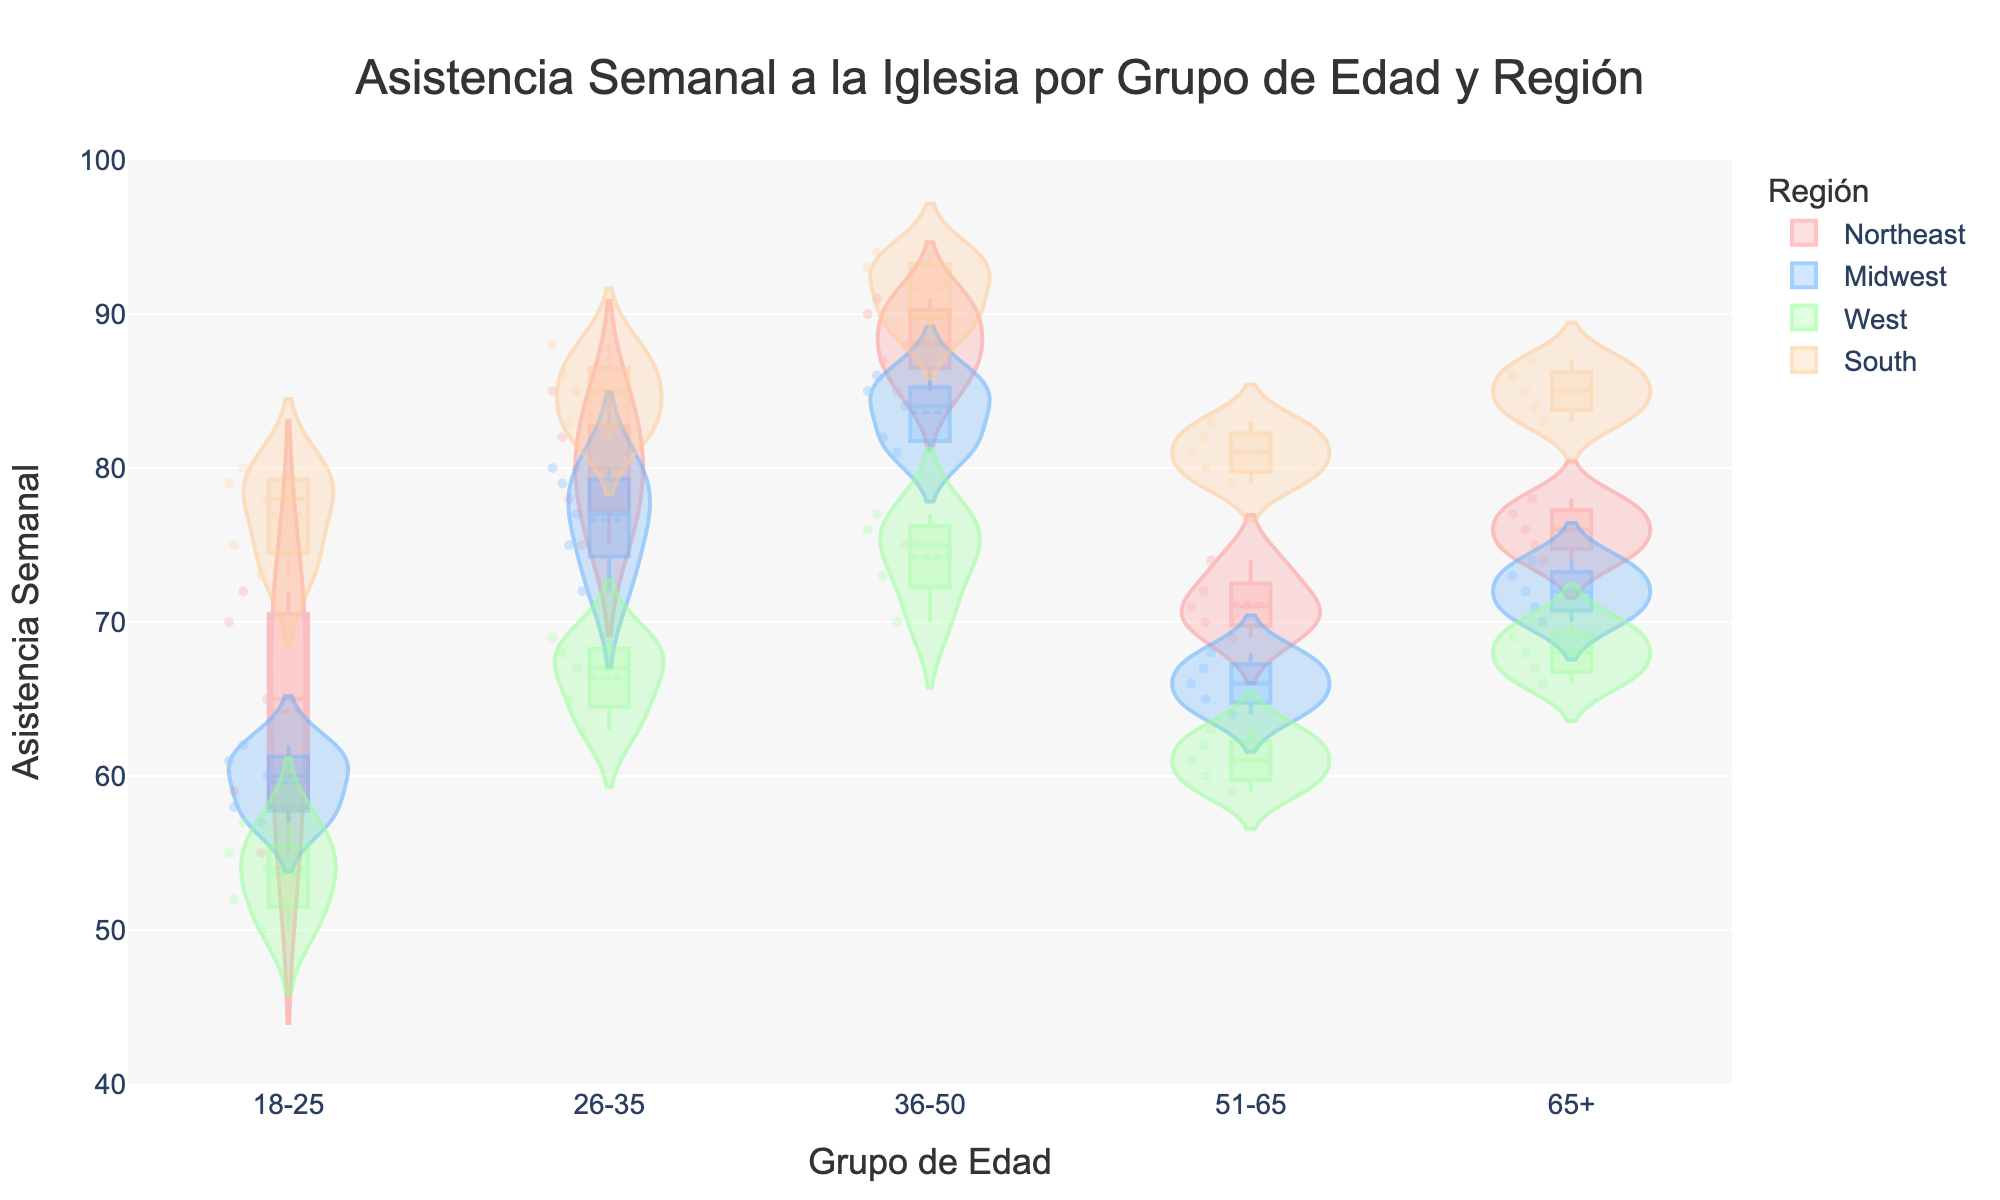What's the title of the figure? The title is positioned at the top center of the figure and typically describes the content depicted in the chart. In this case, it is written in Spanish.
Answer: Asistencia Semanal a la Iglesia por Grupo de Edad y Región Which region has the highest median weekly attendance among 18-25 age group? To find the answer, look for the box plot overlay within the violin plot representing the median values for each region in the 18-25 age group. The region with the highest median value will be the answer.
Answer: South What's the range of weekly attendance in the Midwest region for 51-65 age group? The range can be determined by finding the highest and lowest points of the violin plot and box plot for the Midwest region within the 51-65 age group.
Answer: 64 - 68 Which age group in the West region has the highest mean weekly attendance? The mean line within the violin plots for each age group in the West region indicates the average weekly attendance. Identify the age group with the highest mean line.
Answer: 36-50 How does the median weekly attendance compare between the Northeast and Midwest for the 65+ age group? Find the median line within the box plots for the 65+ age group in both the Northeast and Midwest regions. Compare the values to determine which region has a higher median.
Answer: Northeast > Midwest In the South region, which age group shows the widest distribution in weekly attendance? The width of the violin plot indicates the distribution of the data points. The age group with the widest violin spread represents the widest distribution.
Answer: 36-50 Which region has the most consistent weekly attendance for the 26-35 age group? Consistency can be interpreted by looking at the range and spread of the violin plot and box plot. The region with the smallest spread within the 26-35 group is the most consistent.
Answer: Midwest Across all regions, which age group has the lowest median weekly attendance? Evaluate the median lines within the box plots for each age group across all regions and identify the age group with the lowest median.
Answer: 18-25 What is the interquartile range (IQR) for the 36-50 age group in the Northeast region? The IQR is the range between the first quartile (25th percentile) and the third quartile (75th percentile) in the box plot. For the Northeast region's 36-50 age group, identify these values and compute the difference.
Answer: 87 - 90 Among the age groups in the South region, which shows the highest variability in weekly attendance? Variability can be assessed by observing the width and spread of the violin plot for each age group. The age group with the largest spread indicates the highest variability.
Answer: 36-50 